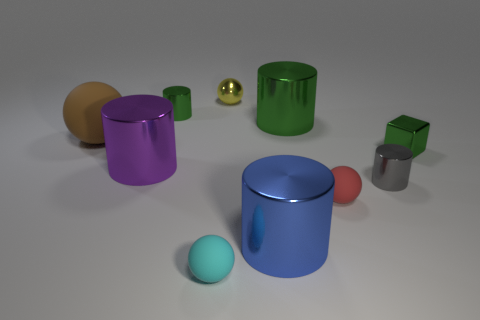Are there more things left of the tiny green cube than green metal cubes that are in front of the blue cylinder?
Your answer should be compact. Yes. What shape is the tiny thing that is behind the gray cylinder and in front of the brown rubber object?
Give a very brief answer. Cube. What is the shape of the tiny green thing behind the big ball?
Give a very brief answer. Cylinder. How big is the green metal cylinder right of the small green thing behind the big shiny thing that is behind the large purple cylinder?
Keep it short and to the point. Large. Does the tiny yellow object have the same shape as the large matte thing?
Your answer should be compact. Yes. What size is the matte sphere that is both on the left side of the red thing and behind the small cyan rubber thing?
Make the answer very short. Large. There is another cyan object that is the same shape as the large matte object; what is it made of?
Make the answer very short. Rubber. There is a ball that is to the left of the small sphere that is to the left of the small yellow ball; what is its material?
Keep it short and to the point. Rubber. There is a small cyan matte thing; does it have the same shape as the rubber object on the right side of the yellow thing?
Provide a succinct answer. Yes. What number of metal objects are small cylinders or cylinders?
Your response must be concise. 5. 